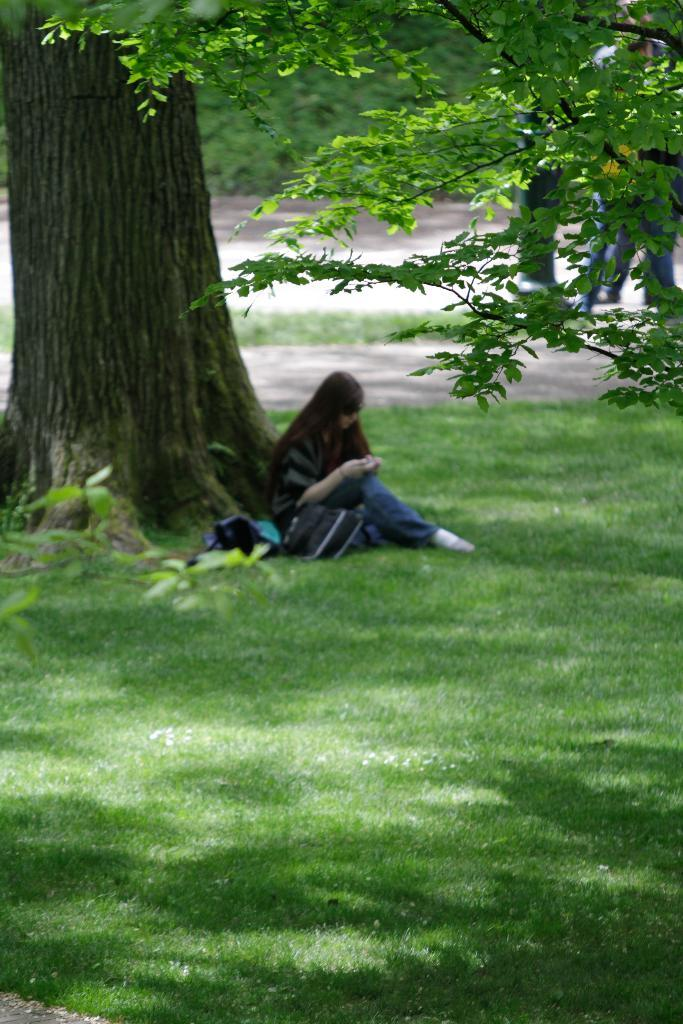What is the woman in the image doing? The woman is sitting on the ground in the image. What object can be seen near the woman? There is a bag in the image. What type of natural environment is visible in the image? There is grass and trees in the image. What else can be seen in the image besides the woman and the bag? There are persons on the road in the image. What type of doctor is attending to the ducks in the image? There are no ducks or doctors present in the image. 